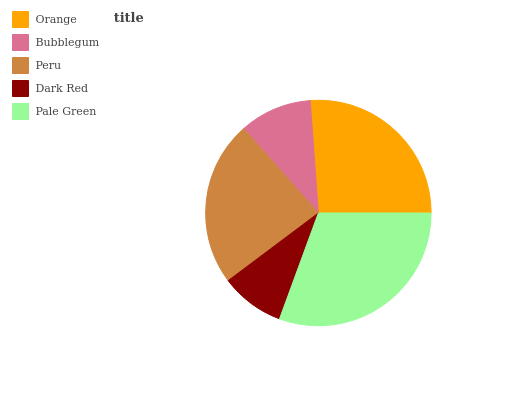Is Dark Red the minimum?
Answer yes or no. Yes. Is Pale Green the maximum?
Answer yes or no. Yes. Is Bubblegum the minimum?
Answer yes or no. No. Is Bubblegum the maximum?
Answer yes or no. No. Is Orange greater than Bubblegum?
Answer yes or no. Yes. Is Bubblegum less than Orange?
Answer yes or no. Yes. Is Bubblegum greater than Orange?
Answer yes or no. No. Is Orange less than Bubblegum?
Answer yes or no. No. Is Peru the high median?
Answer yes or no. Yes. Is Peru the low median?
Answer yes or no. Yes. Is Bubblegum the high median?
Answer yes or no. No. Is Bubblegum the low median?
Answer yes or no. No. 